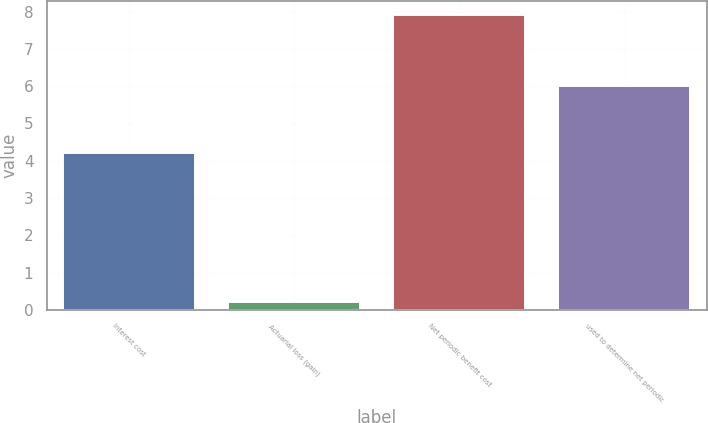<chart> <loc_0><loc_0><loc_500><loc_500><bar_chart><fcel>Interest cost<fcel>Actuarial loss (gain)<fcel>Net periodic benefit cost<fcel>used to determine net periodic<nl><fcel>4.2<fcel>0.2<fcel>7.9<fcel>6<nl></chart> 